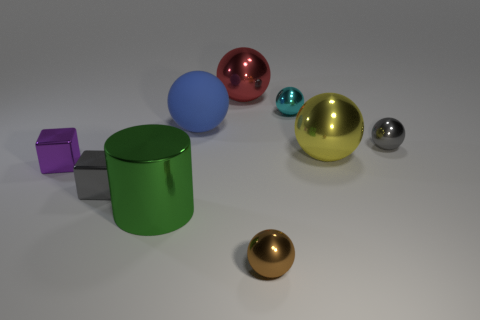Subtract all tiny cyan metallic spheres. How many spheres are left? 5 Subtract all brown spheres. How many spheres are left? 5 Subtract all purple spheres. Subtract all red blocks. How many spheres are left? 6 Add 1 large cyan metallic balls. How many objects exist? 10 Subtract all spheres. How many objects are left? 3 Subtract all large purple matte cylinders. Subtract all yellow metallic things. How many objects are left? 8 Add 7 green metallic things. How many green metallic things are left? 8 Add 8 tiny brown metal objects. How many tiny brown metal objects exist? 9 Subtract 0 blue blocks. How many objects are left? 9 